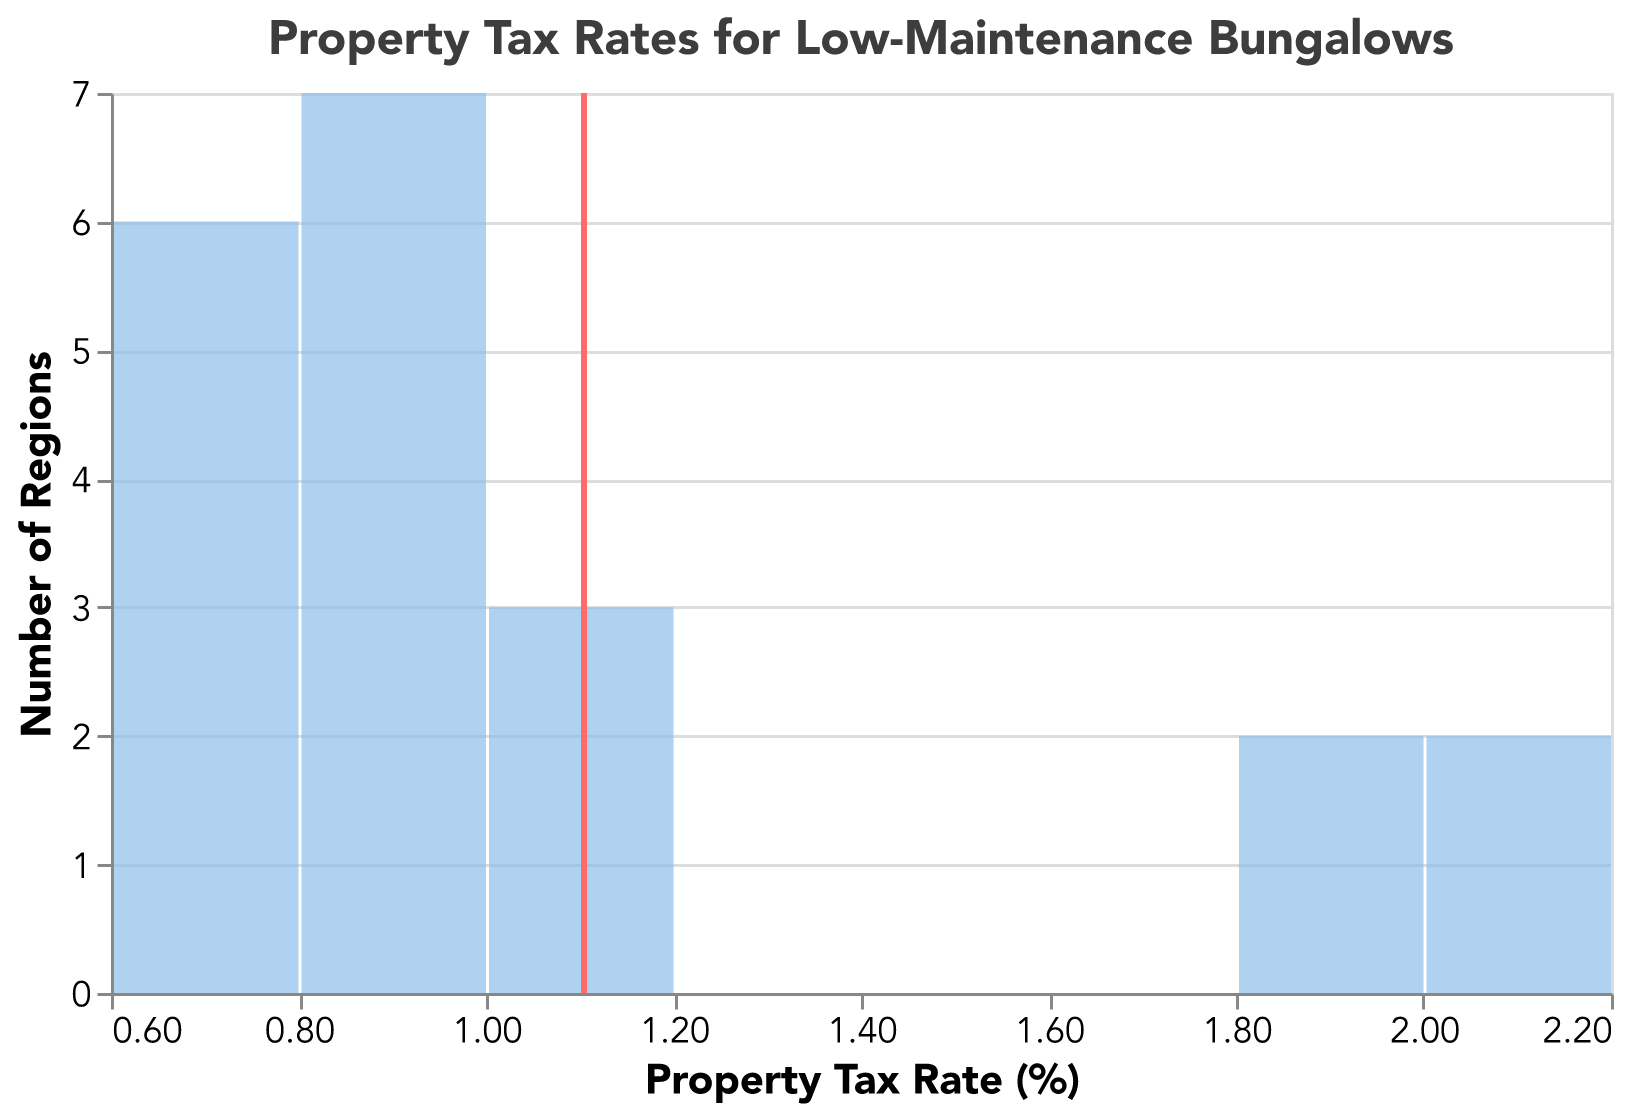What is the mean property tax rate? The mean property tax rate is represented by the vertical red rule in the plot. Place the cursor at the rule to see the numeric value in the tooltip.
Answer: 1.17 How many regions have a property tax rate between 0.6% and 0.8%? Identify the bar segment between 0.6% and 0.8% on the x-axis and check the height of the bar to determine the count of regions in this range.
Answer: 5 Which region has the highest property tax rate? This can't be directly deduced from the plot since only aggregated data is shown. But from the data, the region with the highest rate is known.
Answer: Austin What is the range of property tax rates presented in the plot? Look from the lowest to the highest bins on the x-axis to identify the smallest and largest bins with positive counts. The lowest is 0.6% and the highest is 2.2%.
Answer: 0.6% to 2.2% How many regions have the property tax rate below the mean? Identify regions with a tax rate below the vertical mean line (1.17%). Then, sum the heights of the bars to the left of this line.
Answer: 13 Compare the number of regions with low and medium maintenance costs having tax rates between 0.9% and 1.0%. From the data within the specified range (0.9 to 1.0%), count regions for each maintenance cost category: Miami, Tampa, Charleston (Low), and Orlando, Raleigh (Medium).
Answer: 3 for Low, 2 for Medium Does any region have a property tax rate significantly lower than the mean? Yes, identify bars left to the mean vertical line with much lower values than 1.17%. Notably, tax rates like 0.64% and 0.65% are significantly lower.
Answer: Yes Which maintenance cost category appears most frequently among regions with property tax rates below 1.0%? From the data, filter regions with property tax rates below 1.0% and count how many of each maintenance cost category occur most often.
Answer: Low Are there more regions with property tax rates above or below 1.5%? Sum the counts of regions from bins above and below 1.5% on the x-axis for comparison; count below the threshold should be greater.
Answer: Below What's the difference between the highest and the average property tax rates? The highest rate is 2.10% (Austin), and the mean rate is approximately 1.17%. Subtract the mean from the highest rate for the difference.
Answer: 0.93 